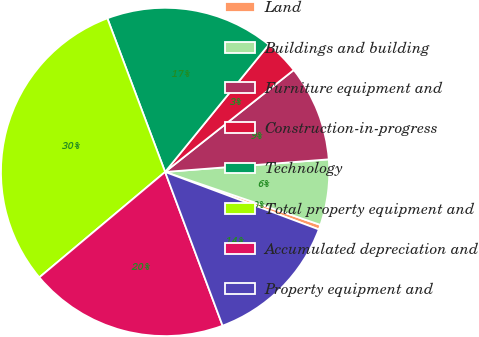Convert chart. <chart><loc_0><loc_0><loc_500><loc_500><pie_chart><fcel>Land<fcel>Buildings and building<fcel>Furniture equipment and<fcel>Construction-in-progress<fcel>Technology<fcel>Total property equipment and<fcel>Accumulated depreciation and<fcel>Property equipment and<nl><fcel>0.47%<fcel>6.45%<fcel>9.44%<fcel>3.46%<fcel>16.6%<fcel>30.38%<fcel>19.59%<fcel>13.61%<nl></chart> 